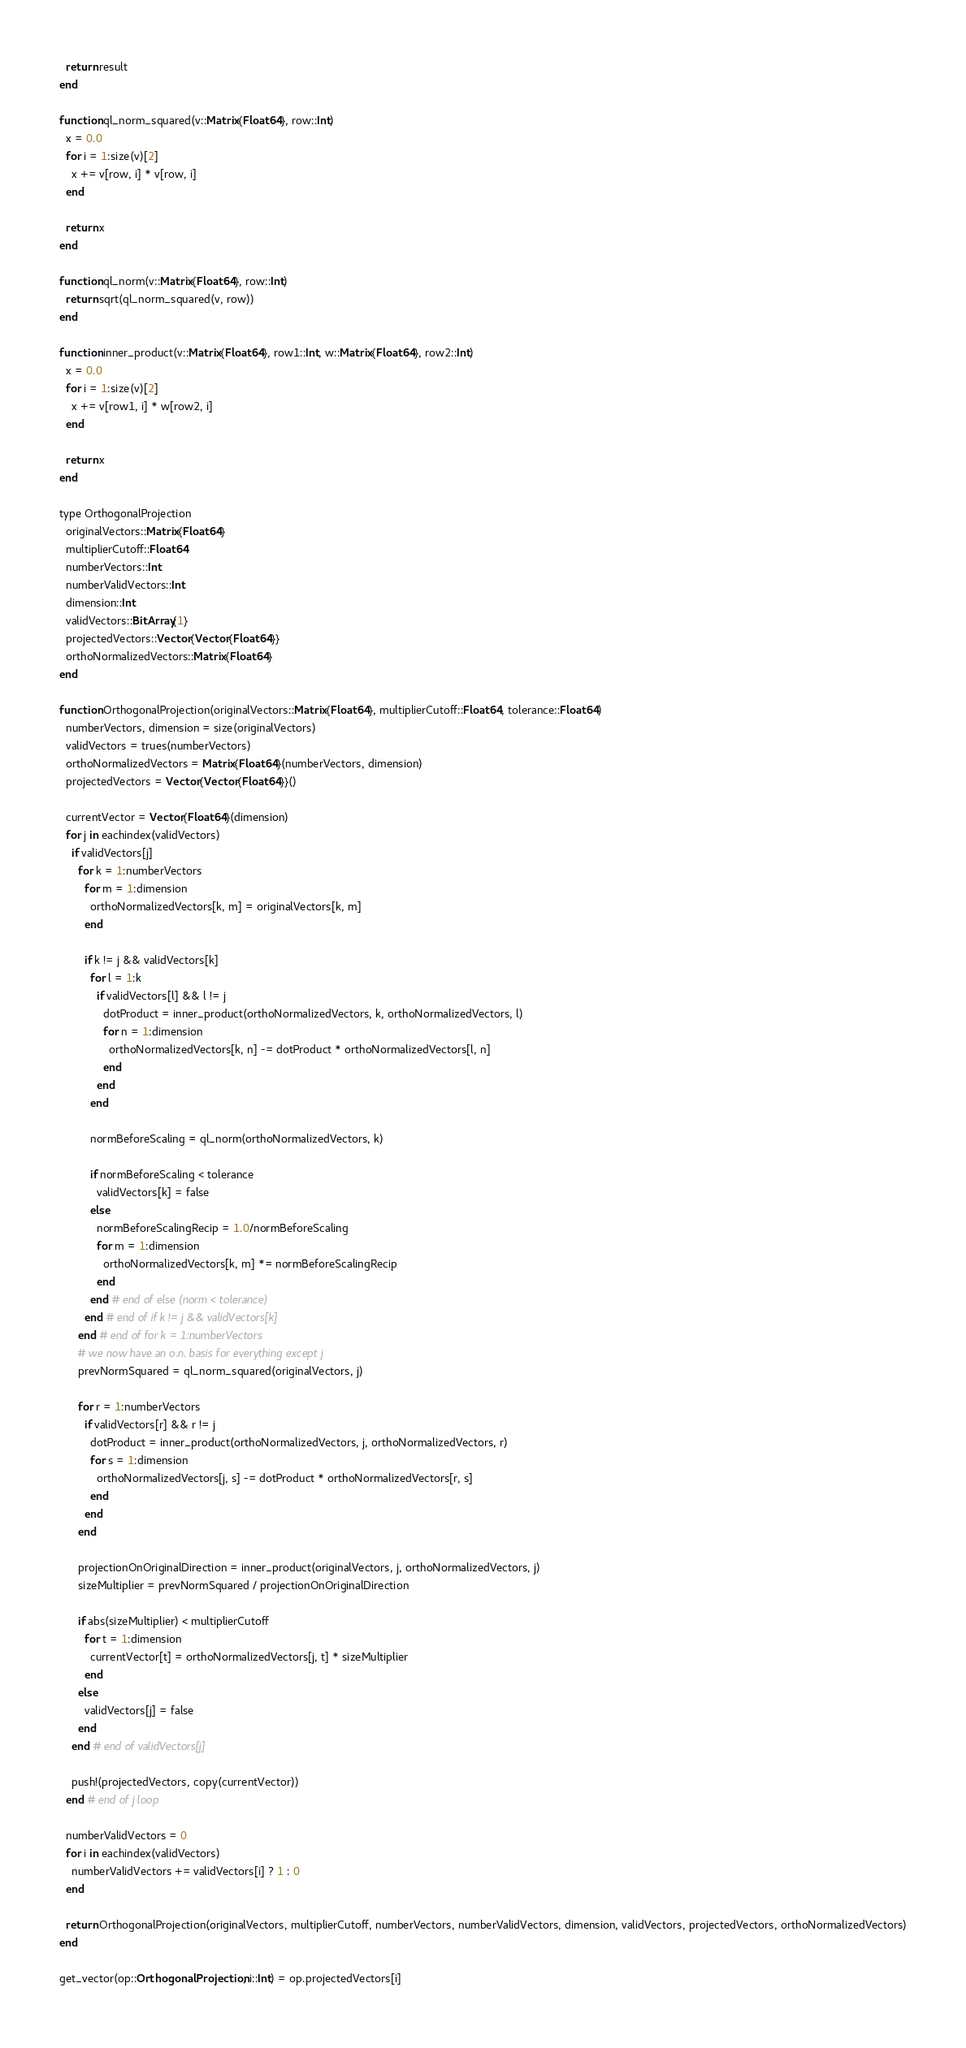Convert code to text. <code><loc_0><loc_0><loc_500><loc_500><_Julia_>  return result
end

function ql_norm_squared(v::Matrix{Float64}, row::Int)
  x = 0.0
  for i = 1:size(v)[2]
    x += v[row, i] * v[row, i]
  end

  return x
end

function ql_norm(v::Matrix{Float64}, row::Int)
  return sqrt(ql_norm_squared(v, row))
end

function inner_product(v::Matrix{Float64}, row1::Int, w::Matrix{Float64}, row2::Int)
  x = 0.0
  for i = 1:size(v)[2]
    x += v[row1, i] * w[row2, i]
  end

  return x
end

type OrthogonalProjection
  originalVectors::Matrix{Float64}
  multiplierCutoff::Float64
  numberVectors::Int
  numberValidVectors::Int
  dimension::Int
  validVectors::BitArray{1}
  projectedVectors::Vector{Vector{Float64}}
  orthoNormalizedVectors::Matrix{Float64}
end

function OrthogonalProjection(originalVectors::Matrix{Float64}, multiplierCutoff::Float64, tolerance::Float64)
  numberVectors, dimension = size(originalVectors)
  validVectors = trues(numberVectors)
  orthoNormalizedVectors = Matrix{Float64}(numberVectors, dimension)
  projectedVectors = Vector{Vector{Float64}}()

  currentVector = Vector{Float64}(dimension)
  for j in eachindex(validVectors)
    if validVectors[j]
      for k = 1:numberVectors
        for m = 1:dimension
          orthoNormalizedVectors[k, m] = originalVectors[k, m]
        end

        if k != j && validVectors[k]
          for l = 1:k
            if validVectors[l] && l != j
              dotProduct = inner_product(orthoNormalizedVectors, k, orthoNormalizedVectors, l)
              for n = 1:dimension
                orthoNormalizedVectors[k, n] -= dotProduct * orthoNormalizedVectors[l, n]
              end
            end
          end

          normBeforeScaling = ql_norm(orthoNormalizedVectors, k)

          if normBeforeScaling < tolerance
            validVectors[k] = false
          else
            normBeforeScalingRecip = 1.0/normBeforeScaling
            for m = 1:dimension
              orthoNormalizedVectors[k, m] *= normBeforeScalingRecip
            end
          end # end of else (norm < tolerance)
        end # end of if k != j && validVectors[k]
      end # end of for k = 1:numberVectors
      # we now have an o.n. basis for everything except j
      prevNormSquared = ql_norm_squared(originalVectors, j)

      for r = 1:numberVectors
        if validVectors[r] && r != j
          dotProduct = inner_product(orthoNormalizedVectors, j, orthoNormalizedVectors, r)
          for s = 1:dimension
            orthoNormalizedVectors[j, s] -= dotProduct * orthoNormalizedVectors[r, s]
          end
        end
      end

      projectionOnOriginalDirection = inner_product(originalVectors, j, orthoNormalizedVectors, j)
      sizeMultiplier = prevNormSquared / projectionOnOriginalDirection

      if abs(sizeMultiplier) < multiplierCutoff
        for t = 1:dimension
          currentVector[t] = orthoNormalizedVectors[j, t] * sizeMultiplier
        end
      else
        validVectors[j] = false
      end
    end # end of validVectors[j]

    push!(projectedVectors, copy(currentVector))
  end # end of j loop

  numberValidVectors = 0
  for i in eachindex(validVectors)
    numberValidVectors += validVectors[i] ? 1 : 0
  end

  return OrthogonalProjection(originalVectors, multiplierCutoff, numberVectors, numberValidVectors, dimension, validVectors, projectedVectors, orthoNormalizedVectors)
end

get_vector(op::OrthogonalProjection, i::Int) = op.projectedVectors[i]
</code> 